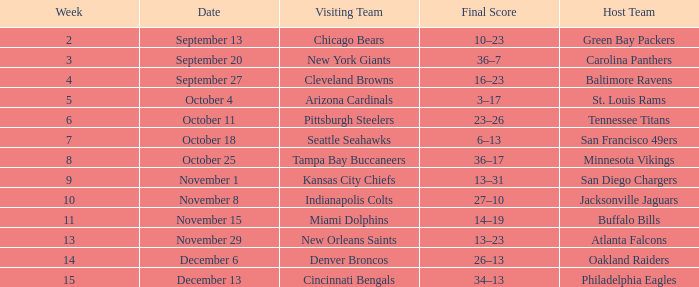What was the final score in week 3 ? 36–7. 